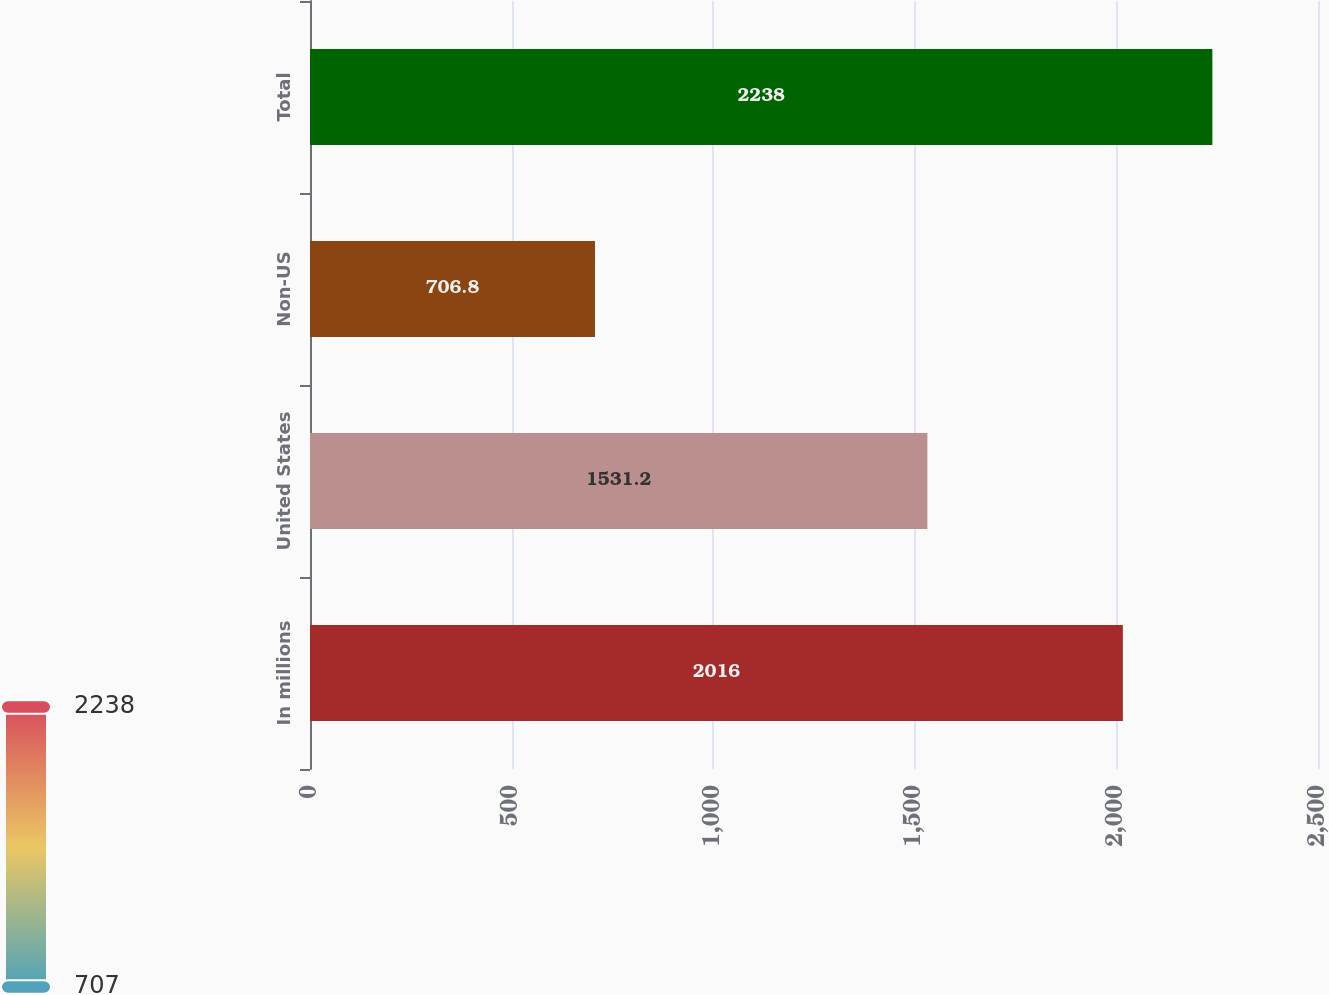Convert chart to OTSL. <chart><loc_0><loc_0><loc_500><loc_500><bar_chart><fcel>In millions<fcel>United States<fcel>Non-US<fcel>Total<nl><fcel>2016<fcel>1531.2<fcel>706.8<fcel>2238<nl></chart> 